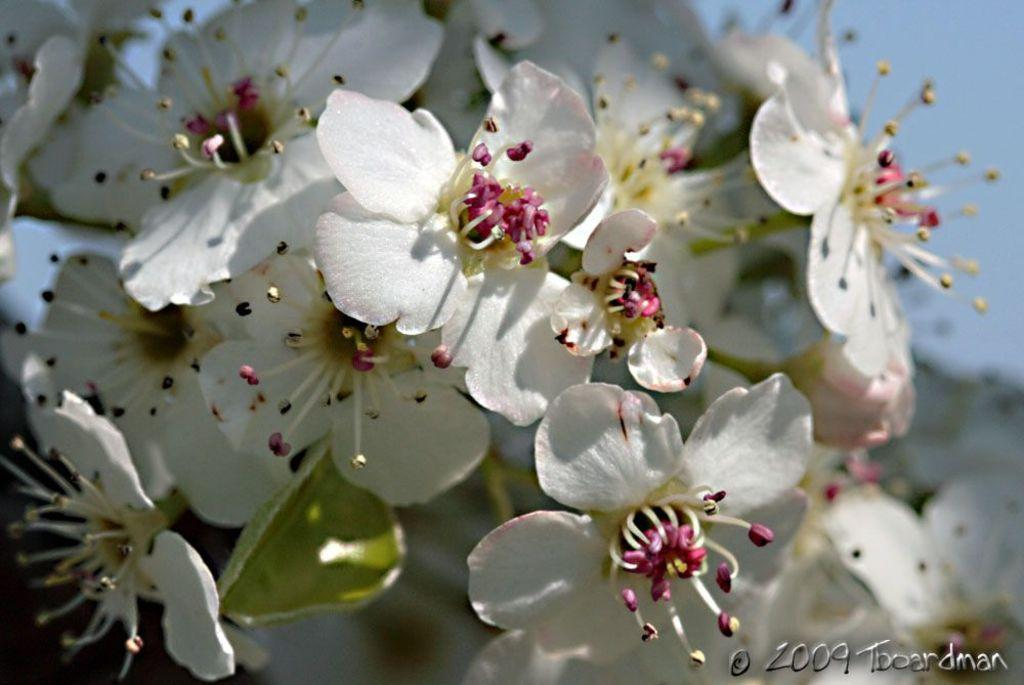What type of flowers can be seen in the image? There are white flowers in the image. Where is the text located in the image? The text is in the bottom right corner of the image. How many holes are visible in the image? There are no holes visible in the image. What number is written in the text in the bottom right corner of the image? The provided facts do not mention any specific number in the text, so we cannot determine the number from the image. 